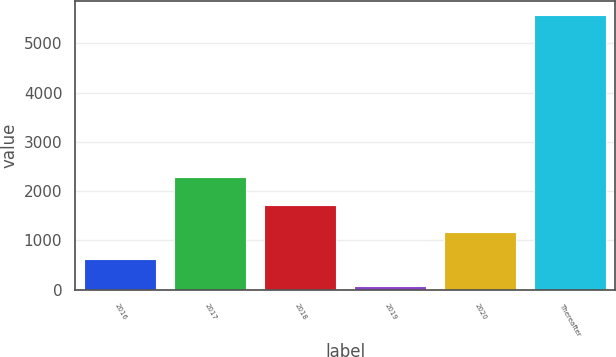Convert chart to OTSL. <chart><loc_0><loc_0><loc_500><loc_500><bar_chart><fcel>2016<fcel>2017<fcel>2018<fcel>2019<fcel>2020<fcel>Thereafter<nl><fcel>632.12<fcel>2278.58<fcel>1729.76<fcel>83.3<fcel>1180.94<fcel>5571.5<nl></chart> 